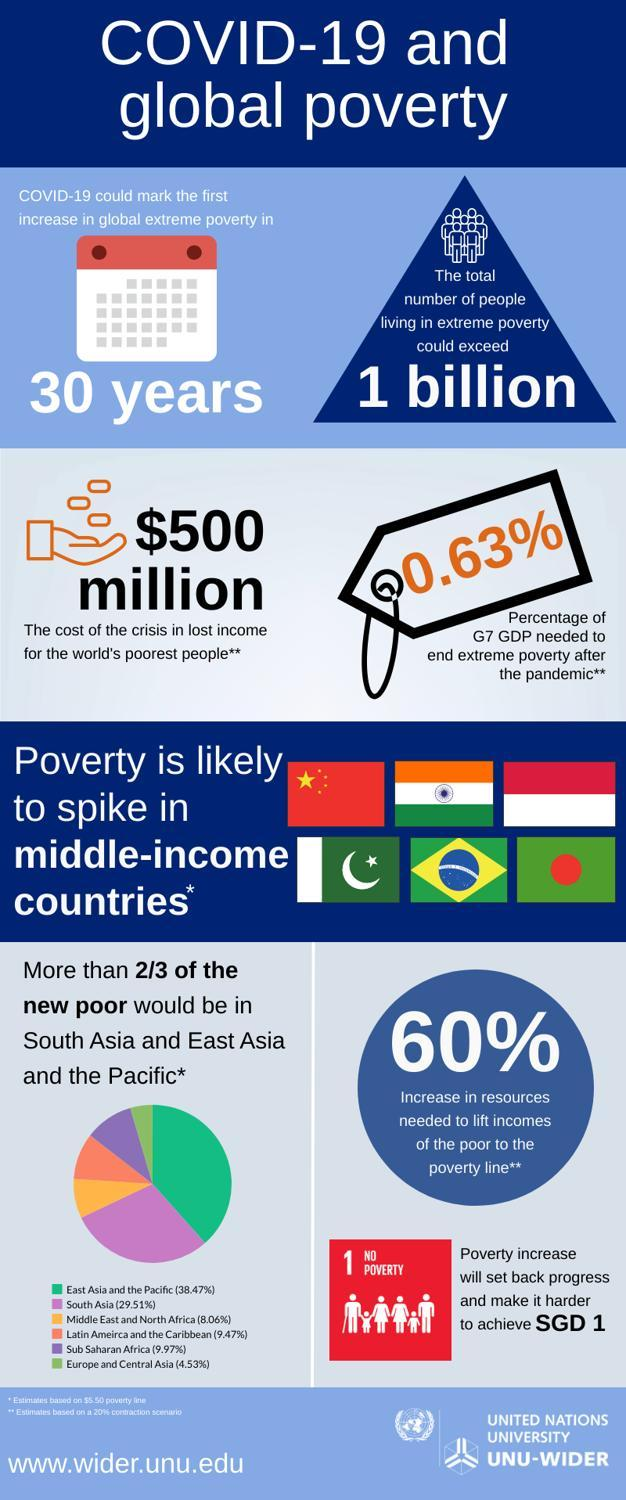What is the inverse percentage of resources required to make the condition of the poor better?
Answer the question with a short phrase. 40 Which is the fourth country which would be poor in the near future due to pandemic? Latin America and the Caribbean What proportion of the Gross Domestic Product is required to stop pandemic crisis? 0.63% Which is the second country expected to hit poverty spike after pandemic- China, Thailand, India, Japan? India Which is the third country which would be poor in the near future due to pandemic? Middle East and North Africa 